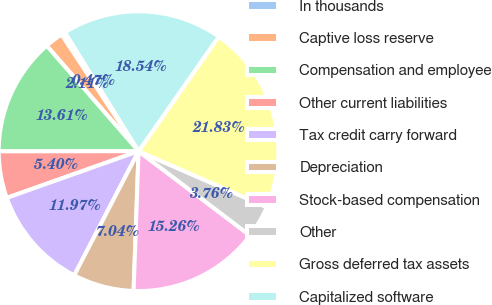<chart> <loc_0><loc_0><loc_500><loc_500><pie_chart><fcel>In thousands<fcel>Captive loss reserve<fcel>Compensation and employee<fcel>Other current liabilities<fcel>Tax credit carry forward<fcel>Depreciation<fcel>Stock-based compensation<fcel>Other<fcel>Gross deferred tax assets<fcel>Capitalized software<nl><fcel>0.47%<fcel>2.11%<fcel>13.61%<fcel>5.4%<fcel>11.97%<fcel>7.04%<fcel>15.26%<fcel>3.76%<fcel>21.83%<fcel>18.54%<nl></chart> 